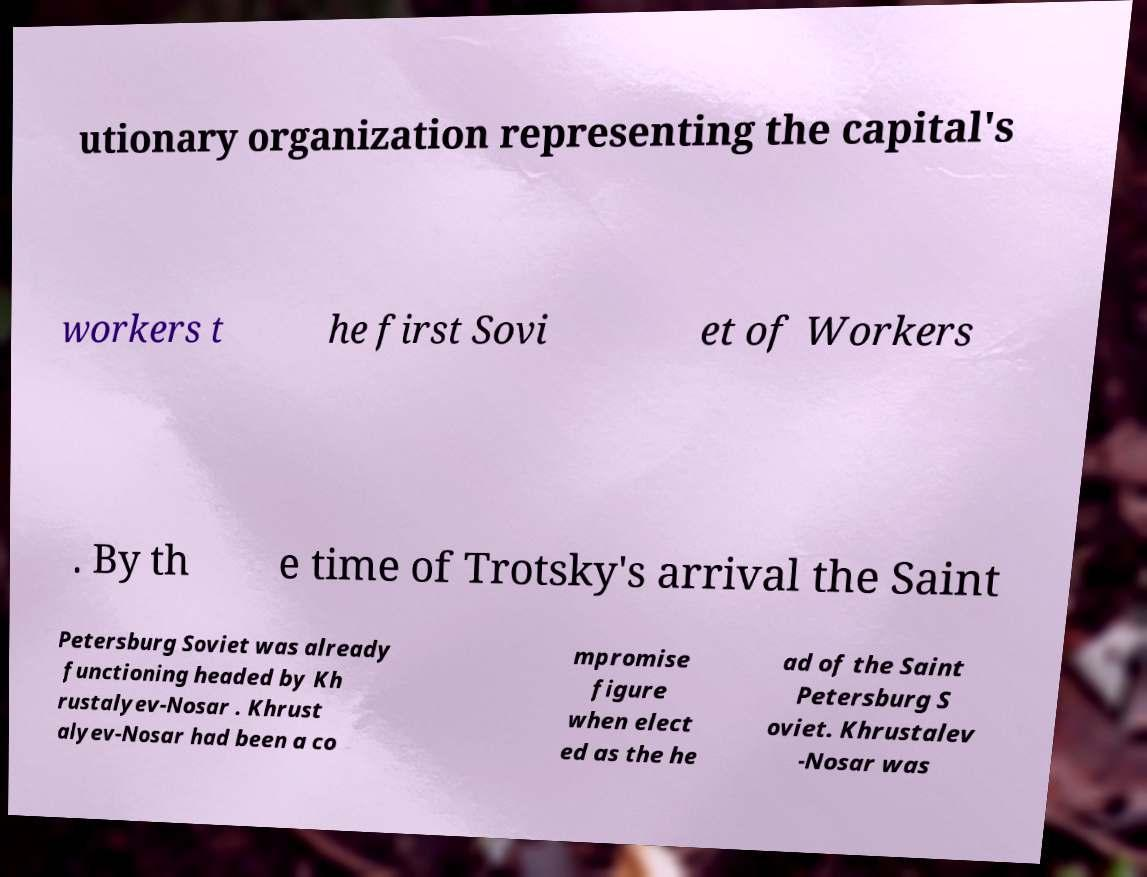Can you read and provide the text displayed in the image?This photo seems to have some interesting text. Can you extract and type it out for me? utionary organization representing the capital's workers t he first Sovi et of Workers . By th e time of Trotsky's arrival the Saint Petersburg Soviet was already functioning headed by Kh rustalyev-Nosar . Khrust alyev-Nosar had been a co mpromise figure when elect ed as the he ad of the Saint Petersburg S oviet. Khrustalev -Nosar was 